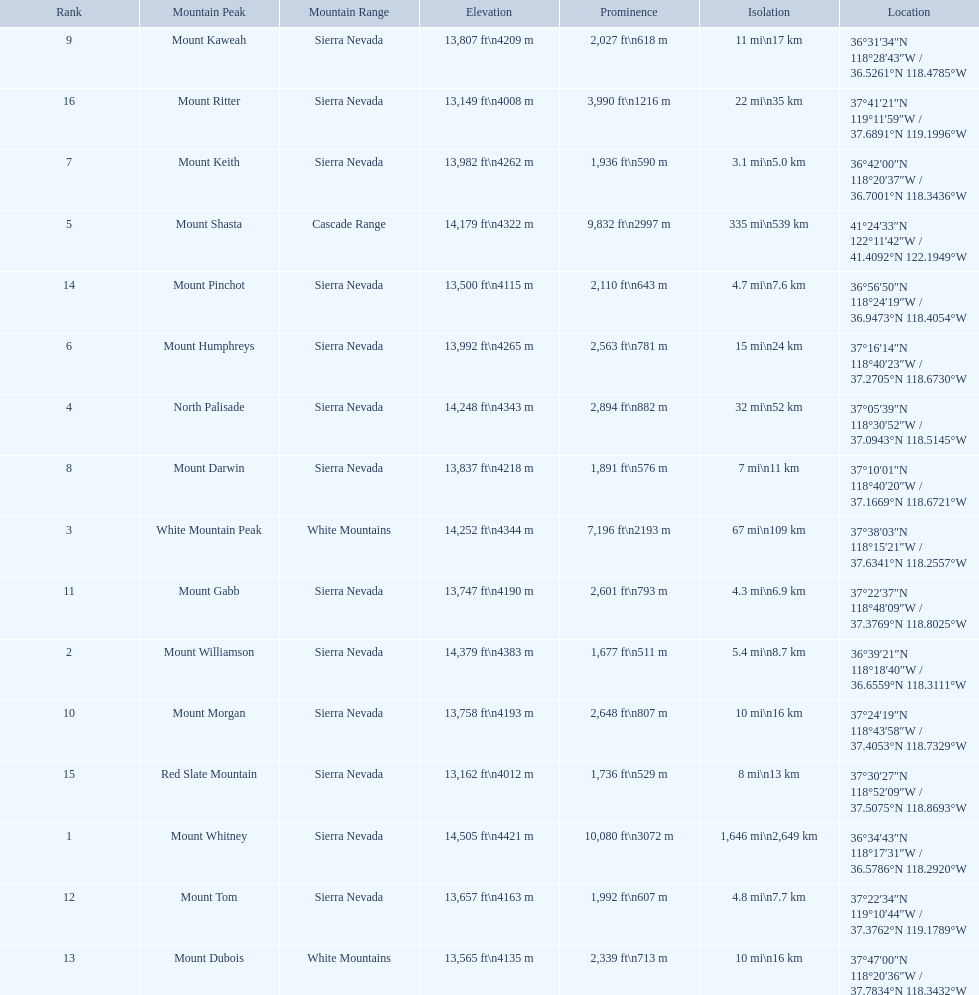Would you mind parsing the complete table? {'header': ['Rank', 'Mountain Peak', 'Mountain Range', 'Elevation', 'Prominence', 'Isolation', 'Location'], 'rows': [['9', 'Mount Kaweah', 'Sierra Nevada', '13,807\xa0ft\\n4209\xa0m', '2,027\xa0ft\\n618\xa0m', '11\xa0mi\\n17\xa0km', '36°31′34″N 118°28′43″W\ufeff / \ufeff36.5261°N 118.4785°W'], ['16', 'Mount Ritter', 'Sierra Nevada', '13,149\xa0ft\\n4008\xa0m', '3,990\xa0ft\\n1216\xa0m', '22\xa0mi\\n35\xa0km', '37°41′21″N 119°11′59″W\ufeff / \ufeff37.6891°N 119.1996°W'], ['7', 'Mount Keith', 'Sierra Nevada', '13,982\xa0ft\\n4262\xa0m', '1,936\xa0ft\\n590\xa0m', '3.1\xa0mi\\n5.0\xa0km', '36°42′00″N 118°20′37″W\ufeff / \ufeff36.7001°N 118.3436°W'], ['5', 'Mount Shasta', 'Cascade Range', '14,179\xa0ft\\n4322\xa0m', '9,832\xa0ft\\n2997\xa0m', '335\xa0mi\\n539\xa0km', '41°24′33″N 122°11′42″W\ufeff / \ufeff41.4092°N 122.1949°W'], ['14', 'Mount Pinchot', 'Sierra Nevada', '13,500\xa0ft\\n4115\xa0m', '2,110\xa0ft\\n643\xa0m', '4.7\xa0mi\\n7.6\xa0km', '36°56′50″N 118°24′19″W\ufeff / \ufeff36.9473°N 118.4054°W'], ['6', 'Mount Humphreys', 'Sierra Nevada', '13,992\xa0ft\\n4265\xa0m', '2,563\xa0ft\\n781\xa0m', '15\xa0mi\\n24\xa0km', '37°16′14″N 118°40′23″W\ufeff / \ufeff37.2705°N 118.6730°W'], ['4', 'North Palisade', 'Sierra Nevada', '14,248\xa0ft\\n4343\xa0m', '2,894\xa0ft\\n882\xa0m', '32\xa0mi\\n52\xa0km', '37°05′39″N 118°30′52″W\ufeff / \ufeff37.0943°N 118.5145°W'], ['8', 'Mount Darwin', 'Sierra Nevada', '13,837\xa0ft\\n4218\xa0m', '1,891\xa0ft\\n576\xa0m', '7\xa0mi\\n11\xa0km', '37°10′01″N 118°40′20″W\ufeff / \ufeff37.1669°N 118.6721°W'], ['3', 'White Mountain Peak', 'White Mountains', '14,252\xa0ft\\n4344\xa0m', '7,196\xa0ft\\n2193\xa0m', '67\xa0mi\\n109\xa0km', '37°38′03″N 118°15′21″W\ufeff / \ufeff37.6341°N 118.2557°W'], ['11', 'Mount Gabb', 'Sierra Nevada', '13,747\xa0ft\\n4190\xa0m', '2,601\xa0ft\\n793\xa0m', '4.3\xa0mi\\n6.9\xa0km', '37°22′37″N 118°48′09″W\ufeff / \ufeff37.3769°N 118.8025°W'], ['2', 'Mount Williamson', 'Sierra Nevada', '14,379\xa0ft\\n4383\xa0m', '1,677\xa0ft\\n511\xa0m', '5.4\xa0mi\\n8.7\xa0km', '36°39′21″N 118°18′40″W\ufeff / \ufeff36.6559°N 118.3111°W'], ['10', 'Mount Morgan', 'Sierra Nevada', '13,758\xa0ft\\n4193\xa0m', '2,648\xa0ft\\n807\xa0m', '10\xa0mi\\n16\xa0km', '37°24′19″N 118°43′58″W\ufeff / \ufeff37.4053°N 118.7329°W'], ['15', 'Red Slate Mountain', 'Sierra Nevada', '13,162\xa0ft\\n4012\xa0m', '1,736\xa0ft\\n529\xa0m', '8\xa0mi\\n13\xa0km', '37°30′27″N 118°52′09″W\ufeff / \ufeff37.5075°N 118.8693°W'], ['1', 'Mount Whitney', 'Sierra Nevada', '14,505\xa0ft\\n4421\xa0m', '10,080\xa0ft\\n3072\xa0m', '1,646\xa0mi\\n2,649\xa0km', '36°34′43″N 118°17′31″W\ufeff / \ufeff36.5786°N 118.2920°W'], ['12', 'Mount Tom', 'Sierra Nevada', '13,657\xa0ft\\n4163\xa0m', '1,992\xa0ft\\n607\xa0m', '4.8\xa0mi\\n7.7\xa0km', '37°22′34″N 119°10′44″W\ufeff / \ufeff37.3762°N 119.1789°W'], ['13', 'Mount Dubois', 'White Mountains', '13,565\xa0ft\\n4135\xa0m', '2,339\xa0ft\\n713\xa0m', '10\xa0mi\\n16\xa0km', '37°47′00″N 118°20′36″W\ufeff / \ufeff37.7834°N 118.3432°W']]} What are the listed elevations? 14,505 ft\n4421 m, 14,379 ft\n4383 m, 14,252 ft\n4344 m, 14,248 ft\n4343 m, 14,179 ft\n4322 m, 13,992 ft\n4265 m, 13,982 ft\n4262 m, 13,837 ft\n4218 m, 13,807 ft\n4209 m, 13,758 ft\n4193 m, 13,747 ft\n4190 m, 13,657 ft\n4163 m, 13,565 ft\n4135 m, 13,500 ft\n4115 m, 13,162 ft\n4012 m, 13,149 ft\n4008 m. Which of those is 13,149 ft or below? 13,149 ft\n4008 m. To what mountain peak does that value correspond? Mount Ritter. 